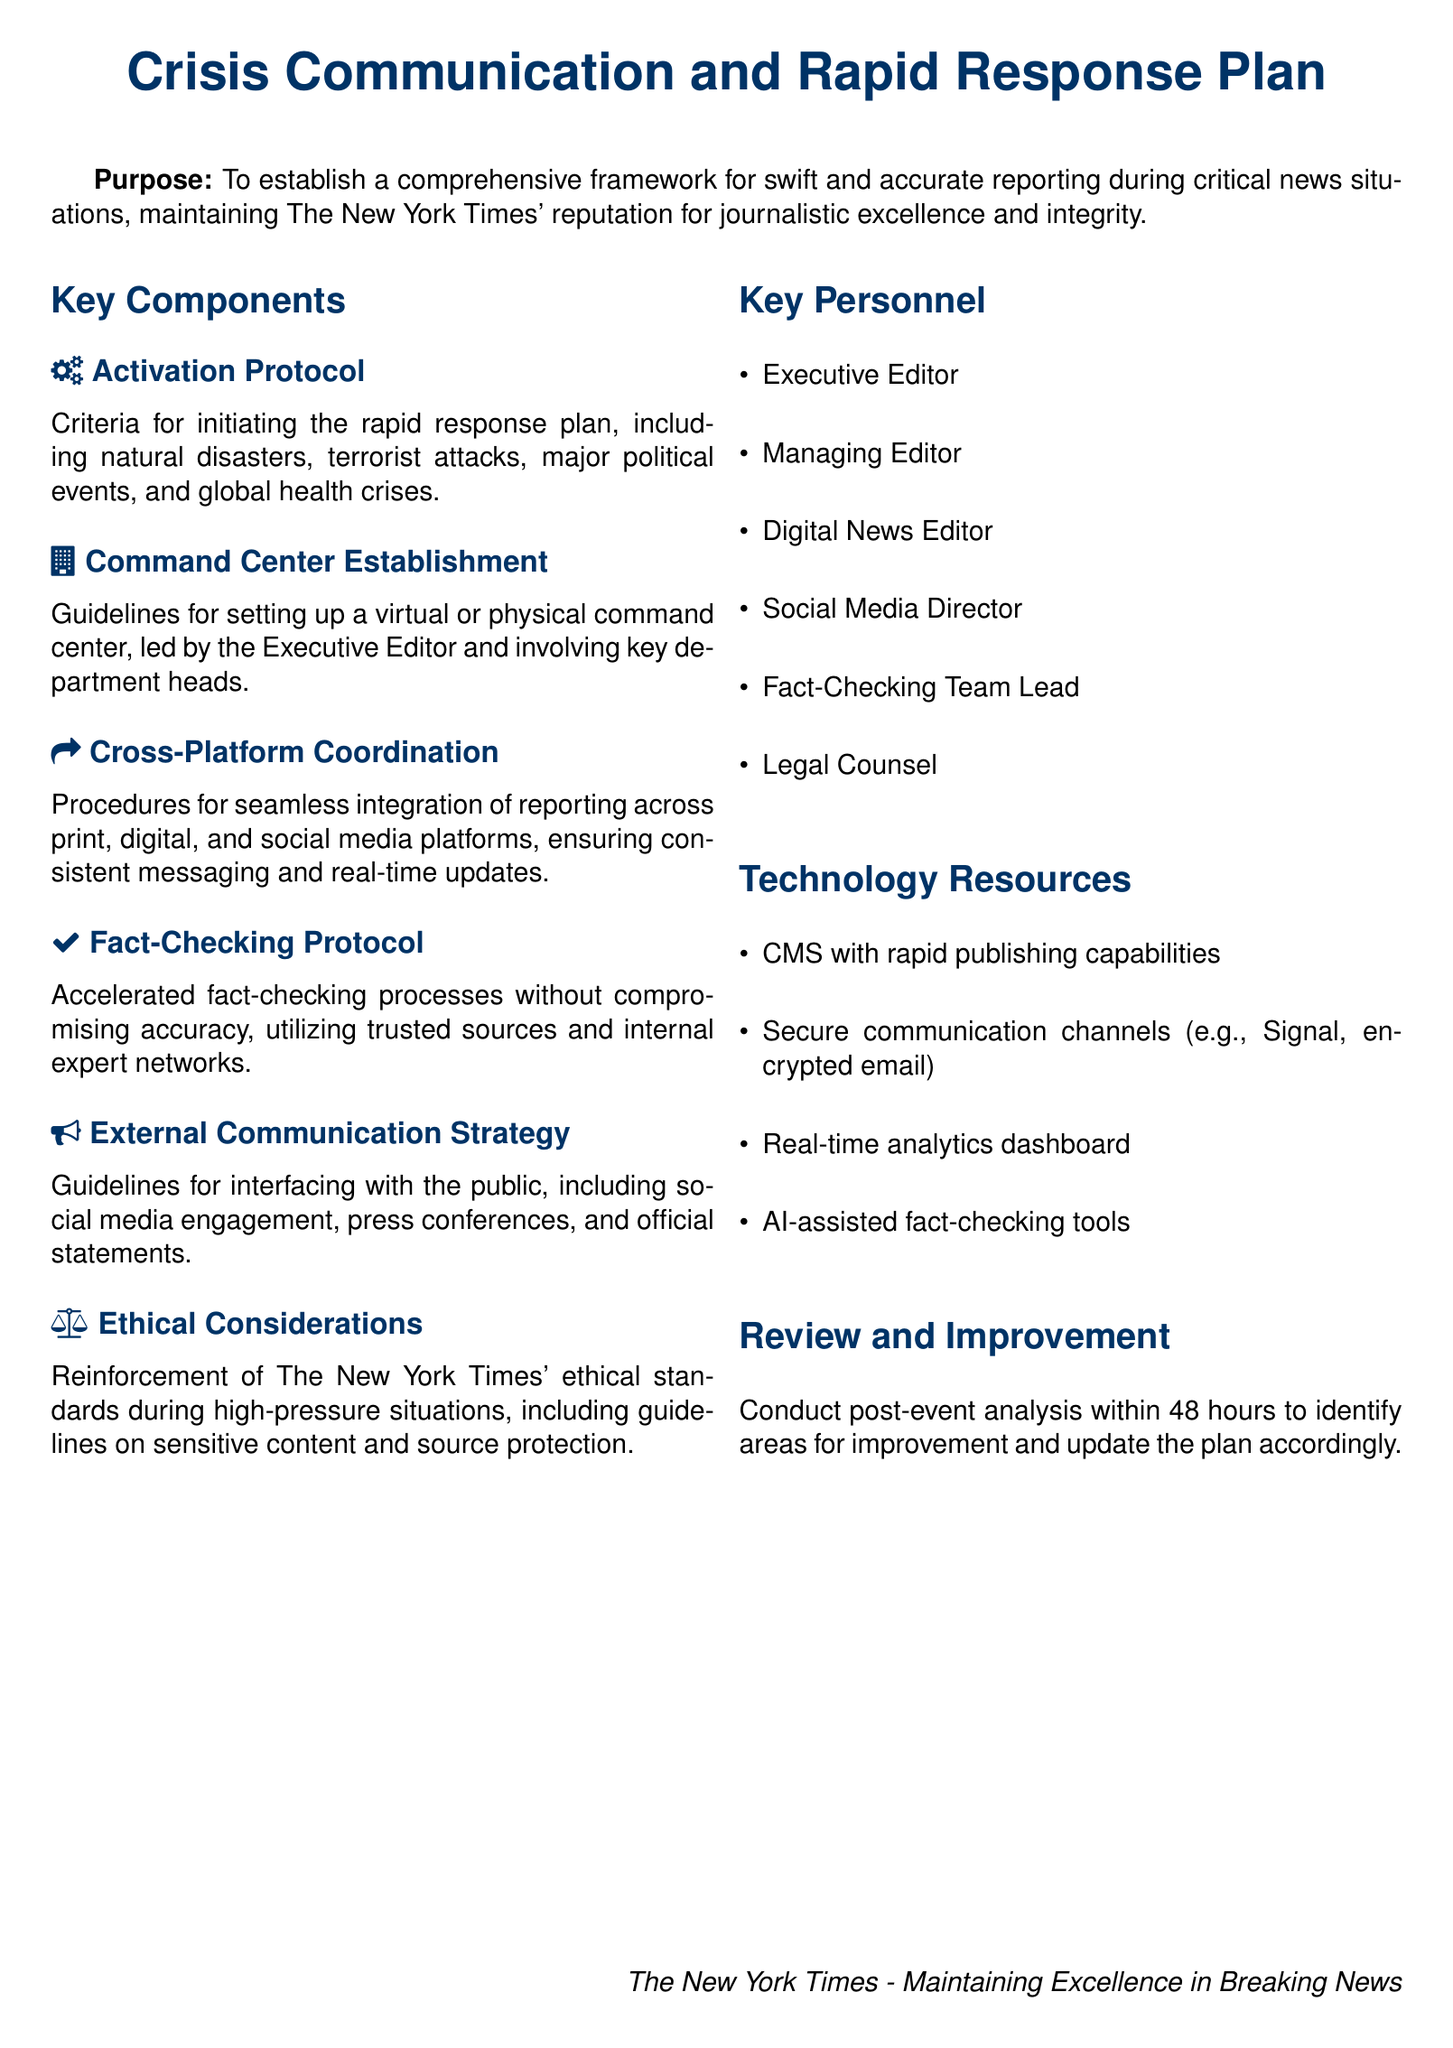What is the purpose of the document? The purpose is stated clearly at the beginning of the document, focusing on establishing a framework for reporting during critical news situations.
Answer: To establish a comprehensive framework for swift and accurate reporting during critical news situations Who leads the command center? The document specifies that the command center is led by the Executive Editor, indicating their role is critical in crisis communication.
Answer: Executive Editor What are the key personnel listed? The document provides a list of key personnel, emphasizing the roles relevant to the crisis plan.
Answer: Executive Editor, Managing Editor, Digital News Editor, Social Media Director, Fact-Checking Team Lead, Legal Counsel What is the time frame for post-event analysis? The document mentions conducting post-event analysis within a specified period after an event to improve the crisis plan.
Answer: 48 hours What technology resource is mentioned for publishing? The document details the technology resources, particularly highlighting a content management system with capabilities for rapid publishing.
Answer: CMS with rapid publishing capabilities What are the criteria for activating the rapid response plan? The document outlines specific situations that trigger the activation of the rapid response plan, indicating varied scenarios.
Answer: Natural disasters, terrorist attacks, major political events, global health crises How is fact-checking addressed in the plan? The document details the fact-checking protocol, emphasizing the process's importance despite the rapid response nature of news events.
Answer: Accelerated fact-checking processes without compromising accuracy What is the focus of the external communication strategy? The document outlines external communication guidelines, emphasizing the importance of public engagement in crisis situations.
Answer: Social media engagement, press conferences, official statements 